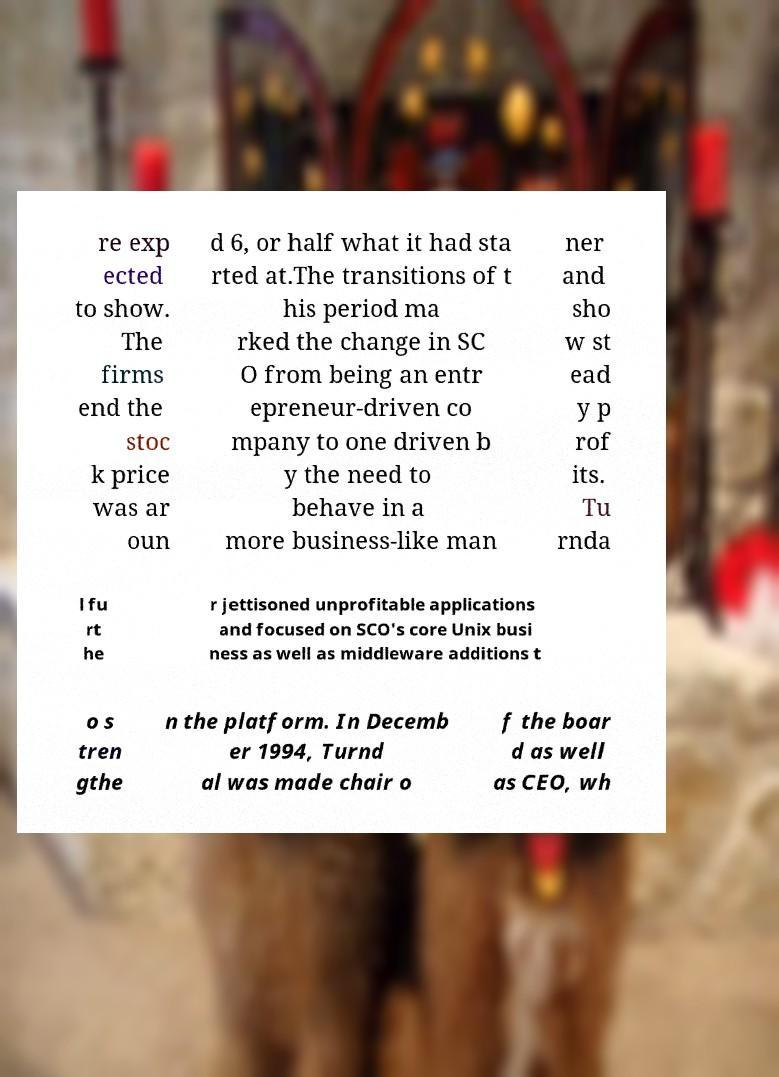Please read and relay the text visible in this image. What does it say? re exp ected to show. The firms end the stoc k price was ar oun d 6, or half what it had sta rted at.The transitions of t his period ma rked the change in SC O from being an entr epreneur-driven co mpany to one driven b y the need to behave in a more business-like man ner and sho w st ead y p rof its. Tu rnda l fu rt he r jettisoned unprofitable applications and focused on SCO's core Unix busi ness as well as middleware additions t o s tren gthe n the platform. In Decemb er 1994, Turnd al was made chair o f the boar d as well as CEO, wh 